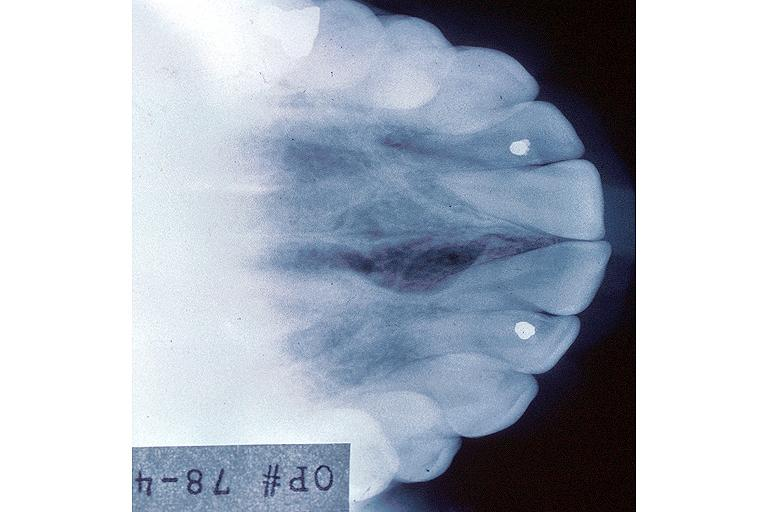what does this image show?
Answer the question using a single word or phrase. Incisive canal cyst nasopalatien duct cyst 